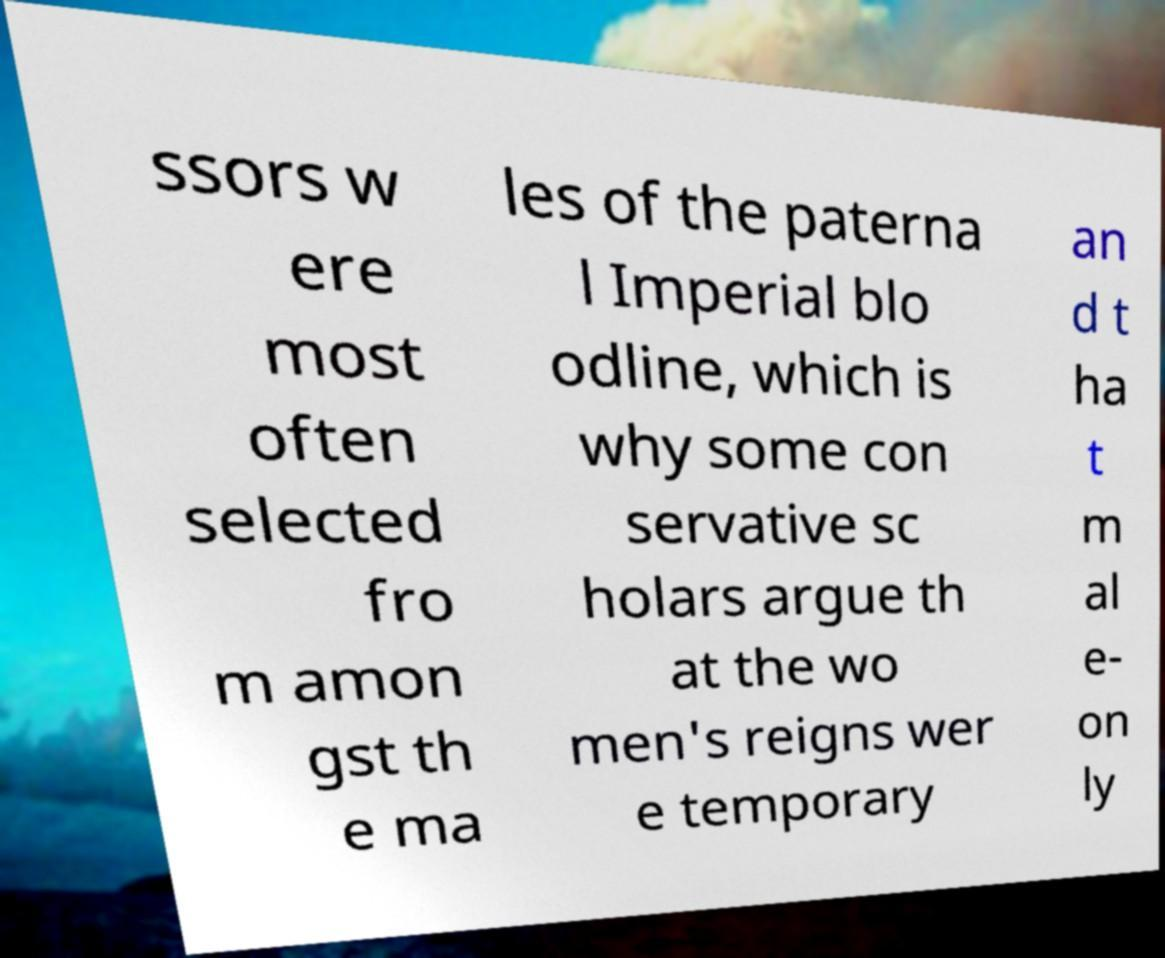I need the written content from this picture converted into text. Can you do that? ssors w ere most often selected fro m amon gst th e ma les of the paterna l Imperial blo odline, which is why some con servative sc holars argue th at the wo men's reigns wer e temporary an d t ha t m al e- on ly 